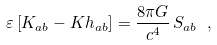Convert formula to latex. <formula><loc_0><loc_0><loc_500><loc_500>\varepsilon \left [ K _ { a b } - K h _ { a b } \right ] = \frac { 8 \pi G } { c ^ { 4 } } \, S _ { a b } \ ,</formula> 